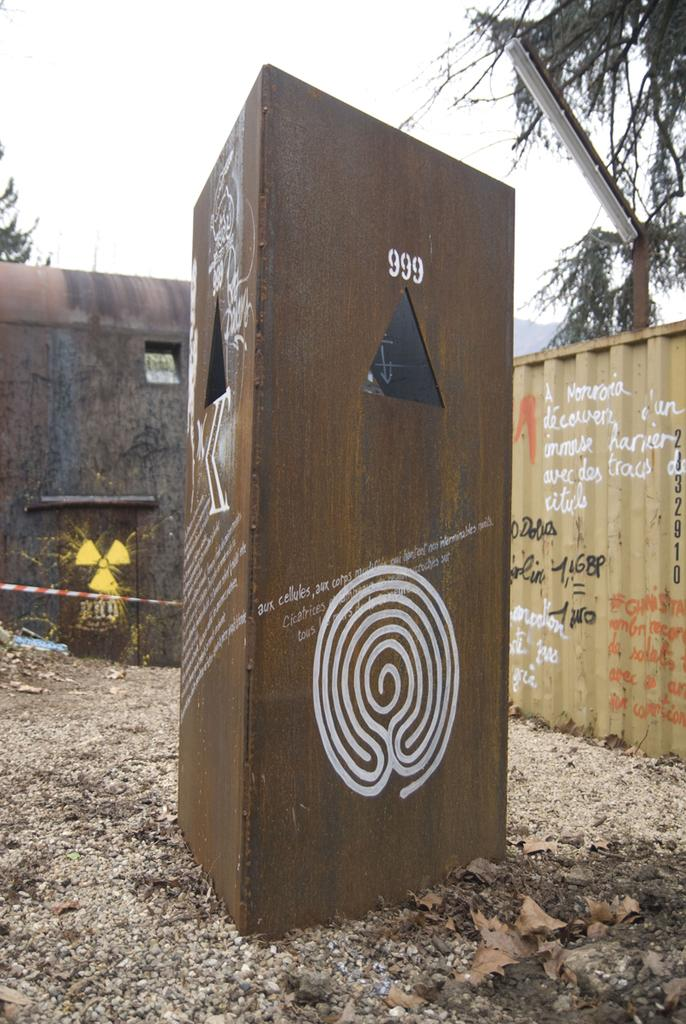What is located in the foreground of the image? There is a cardboard box in the foreground of the image. What other objects can be seen in the image? There is a container and a tube light in the image. What is visible in the background of the image? There is a wall, trees, and the sky visible in the background of the image. How many goldfish are swimming in the container in the image? There is no container with goldfish present in the image. What are the girls doing in the image? There are no girls present in the image. 